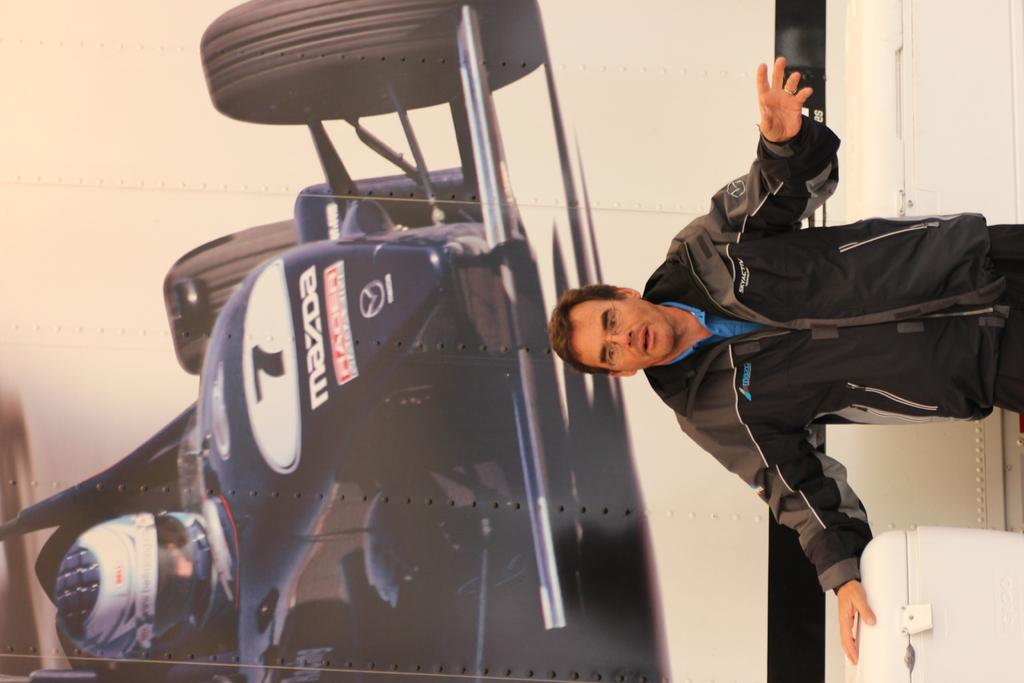<image>
Write a terse but informative summary of the picture. A mazda racing car is in a large picture behind a man in a black sweater. 